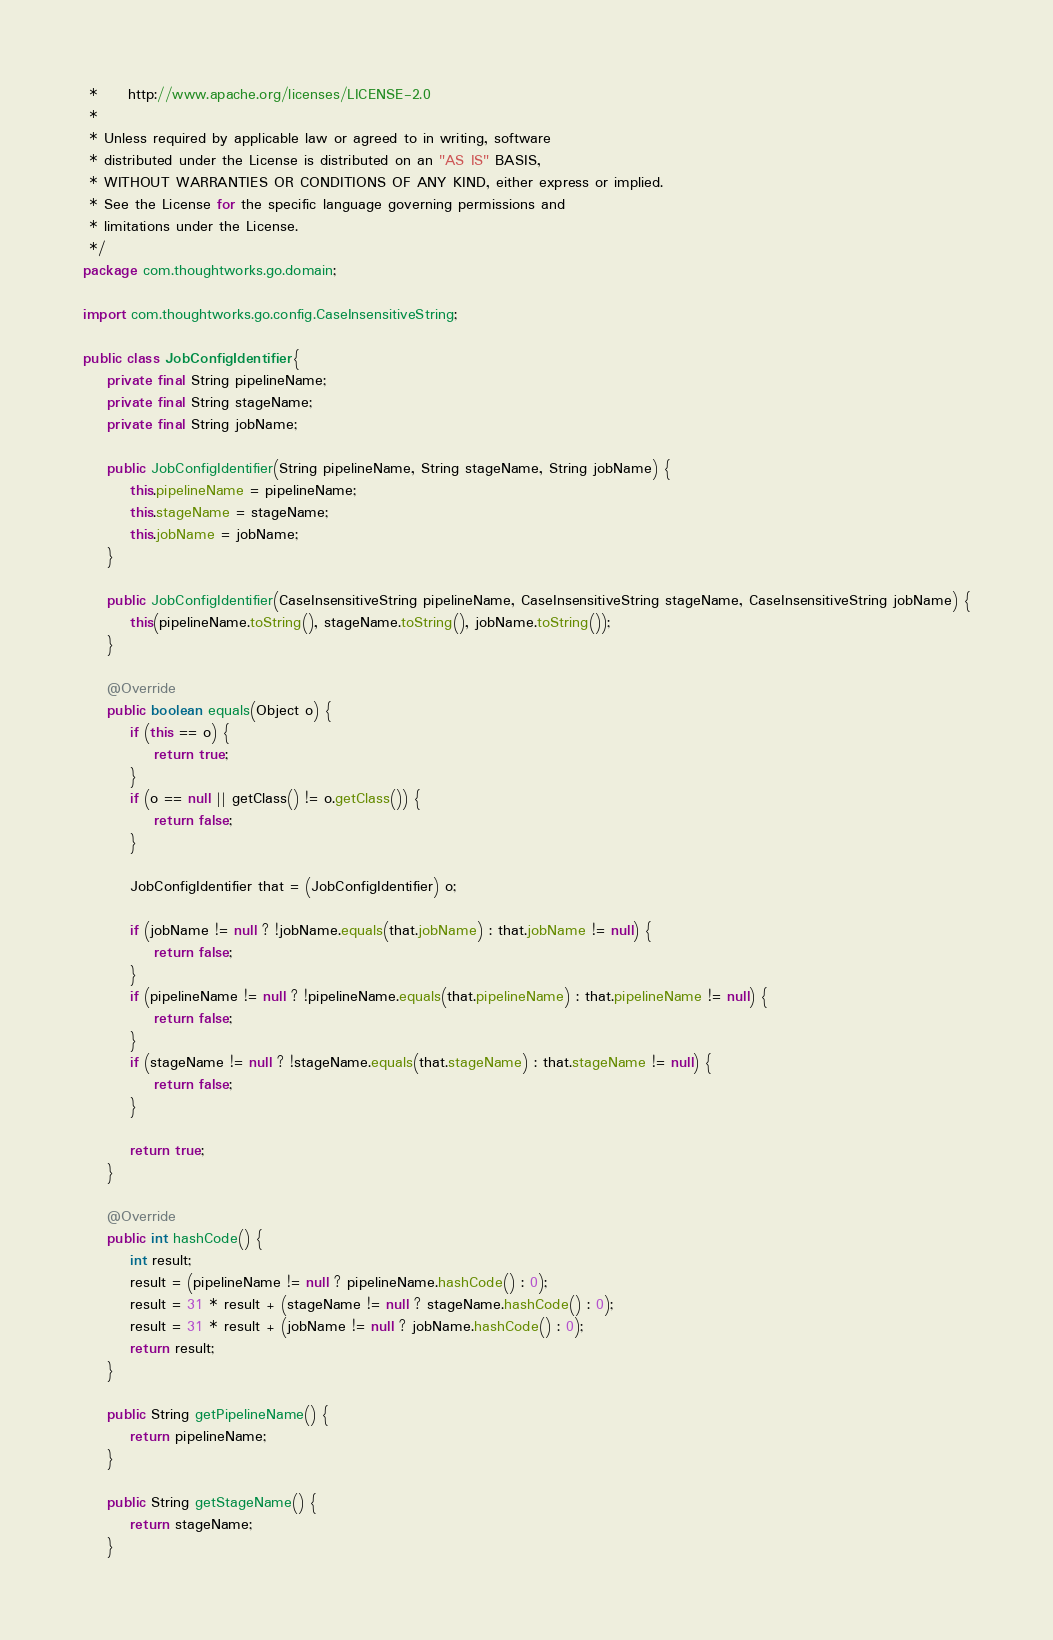<code> <loc_0><loc_0><loc_500><loc_500><_Java_> *     http://www.apache.org/licenses/LICENSE-2.0
 *
 * Unless required by applicable law or agreed to in writing, software
 * distributed under the License is distributed on an "AS IS" BASIS,
 * WITHOUT WARRANTIES OR CONDITIONS OF ANY KIND, either express or implied.
 * See the License for the specific language governing permissions and
 * limitations under the License.
 */
package com.thoughtworks.go.domain;

import com.thoughtworks.go.config.CaseInsensitiveString;

public class JobConfigIdentifier {
    private final String pipelineName;
    private final String stageName;
    private final String jobName;

    public JobConfigIdentifier(String pipelineName, String stageName, String jobName) {
        this.pipelineName = pipelineName;
        this.stageName = stageName;
        this.jobName = jobName;
    }

    public JobConfigIdentifier(CaseInsensitiveString pipelineName, CaseInsensitiveString stageName, CaseInsensitiveString jobName) {
        this(pipelineName.toString(), stageName.toString(), jobName.toString());
    }

    @Override
    public boolean equals(Object o) {
        if (this == o) {
            return true;
        }
        if (o == null || getClass() != o.getClass()) {
            return false;
        }

        JobConfigIdentifier that = (JobConfigIdentifier) o;

        if (jobName != null ? !jobName.equals(that.jobName) : that.jobName != null) {
            return false;
        }
        if (pipelineName != null ? !pipelineName.equals(that.pipelineName) : that.pipelineName != null) {
            return false;
        }
        if (stageName != null ? !stageName.equals(that.stageName) : that.stageName != null) {
            return false;
        }

        return true;
    }

    @Override
    public int hashCode() {
        int result;
        result = (pipelineName != null ? pipelineName.hashCode() : 0);
        result = 31 * result + (stageName != null ? stageName.hashCode() : 0);
        result = 31 * result + (jobName != null ? jobName.hashCode() : 0);
        return result;
    }

    public String getPipelineName() {
        return pipelineName;
    }

    public String getStageName() {
        return stageName;
    }
</code> 